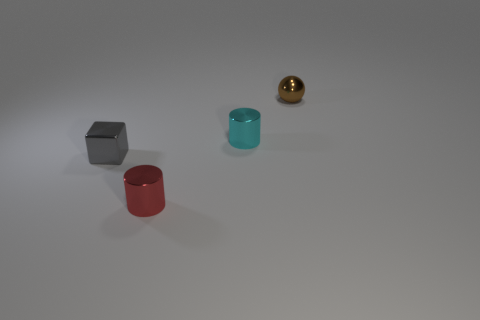Add 4 small gray blocks. How many objects exist? 8 Subtract all cubes. How many objects are left? 3 Subtract all tiny red cylinders. Subtract all small brown matte things. How many objects are left? 3 Add 4 cyan metallic cylinders. How many cyan metallic cylinders are left? 5 Add 2 tiny brown shiny objects. How many tiny brown shiny objects exist? 3 Subtract 0 cyan cubes. How many objects are left? 4 